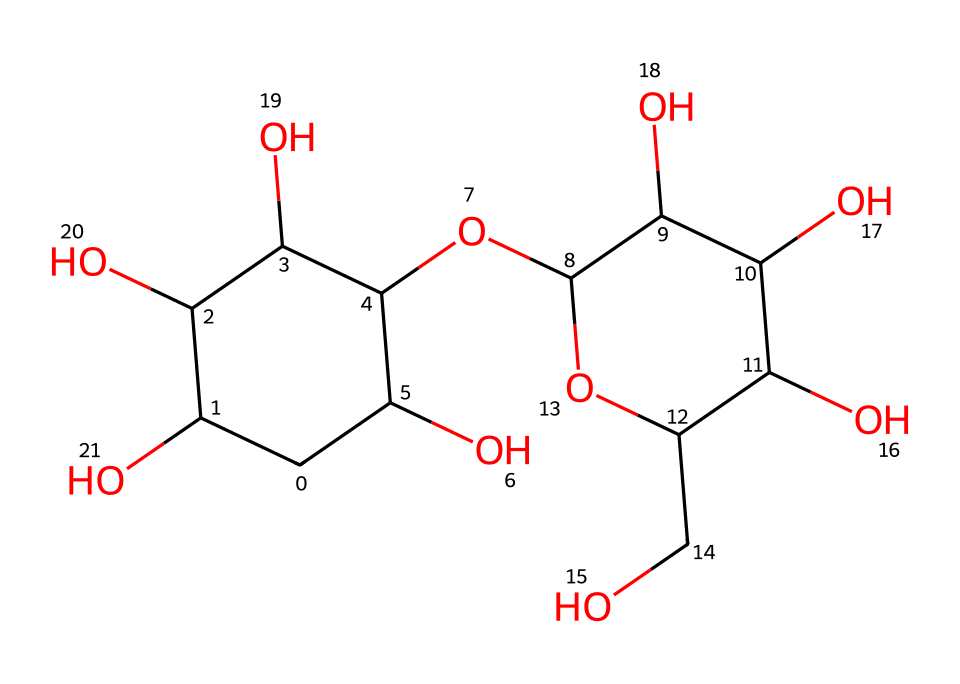What is the chemical name for the compound represented by this SMILES? The SMILES notation represents a polysaccharide, primarily known as amylopectin, which is a major component of corn starch.
Answer: amylopectin How many carbon atoms are in this molecule? By analyzing the SMILES, the total number of 'C' in the representation can be counted. There are 15 carbon atoms present in the given structure.
Answer: 15 What type of molecules are formed when cornstarch is mixed with water to create oobleck? Oobleck is a suspension of cornstarch in water, where the cornstarch molecules form a non-Newtonian fluid that behaves as a solid under pressure.
Answer: suspension Which functional groups are present in this molecule? The structure contains hydroxyl (-OH) groups, which are indicative of its solubility and ability to form hydrogen bonds with water.
Answer: hydroxyl What property allows oobleck to behave as a solid under force? The molecular structure of cornstarch allows for rearrangement under stress, resulting in temporary solid-like behavior due to enhanced intermolecular interactions.
Answer: shear thickening How does the presence of branched structures in this molecule affect its viscosity? The branching in amylopectin contributes to a complex structure that increases viscosity when mixed with water, leading to oobleck's unique flow characteristics under stress.
Answer: increases viscosity 